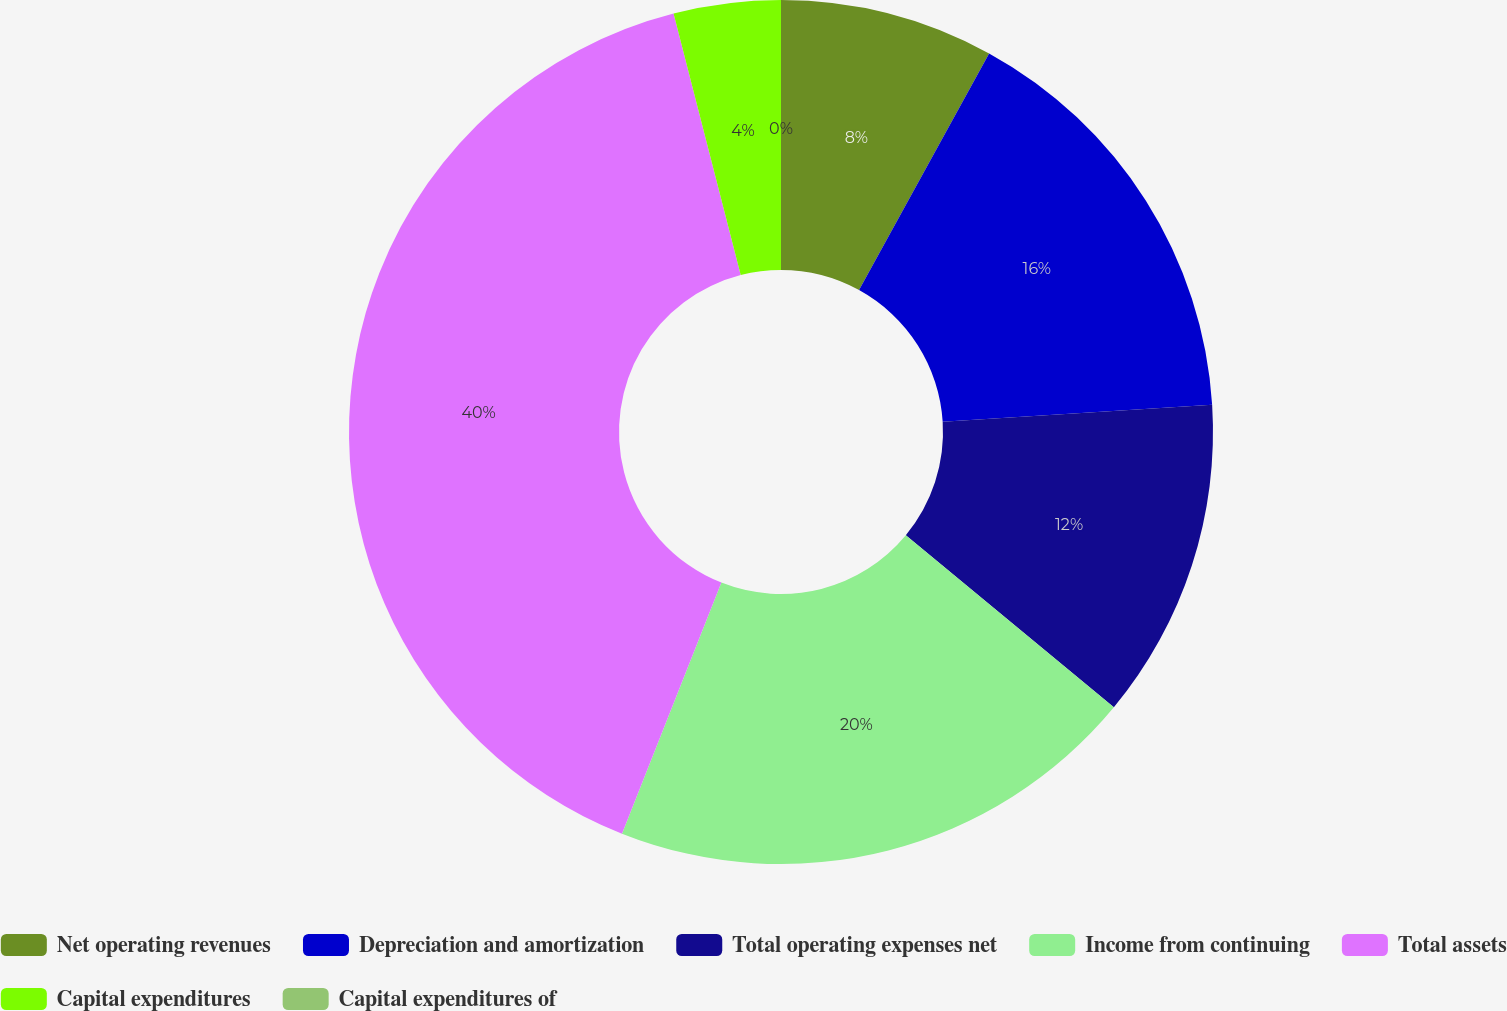Convert chart. <chart><loc_0><loc_0><loc_500><loc_500><pie_chart><fcel>Net operating revenues<fcel>Depreciation and amortization<fcel>Total operating expenses net<fcel>Income from continuing<fcel>Total assets<fcel>Capital expenditures<fcel>Capital expenditures of<nl><fcel>8.0%<fcel>16.0%<fcel>12.0%<fcel>20.0%<fcel>40.0%<fcel>4.0%<fcel>0.0%<nl></chart> 